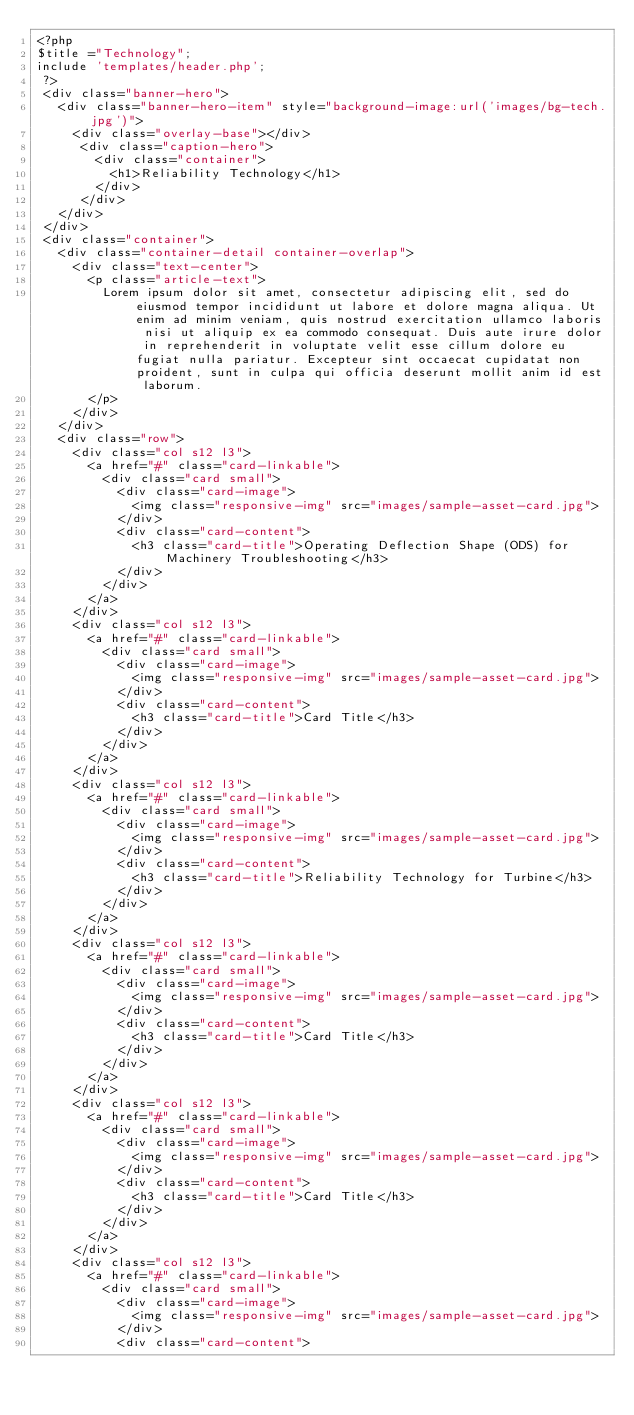<code> <loc_0><loc_0><loc_500><loc_500><_PHP_><?php
$title ="Technology";
include 'templates/header.php';
 ?>
 <div class="banner-hero">
   <div class="banner-hero-item" style="background-image:url('images/bg-tech.jpg')">
     <div class="overlay-base"></div>
      <div class="caption-hero">
        <div class="container">
          <h1>Reliability Technology</h1>
        </div>
      </div>
   </div>
 </div>
 <div class="container">
   <div class="container-detail container-overlap">
     <div class="text-center">
       <p class="article-text">
         Lorem ipsum dolor sit amet, consectetur adipiscing elit, sed do eiusmod tempor incididunt ut labore et dolore magna aliqua. Ut enim ad minim veniam, quis nostrud exercitation ullamco laboris nisi ut aliquip ex ea commodo consequat. Duis aute irure dolor in reprehenderit in voluptate velit esse cillum dolore eu fugiat nulla pariatur. Excepteur sint occaecat cupidatat non proident, sunt in culpa qui officia deserunt mollit anim id est laborum.
       </p>
     </div>
   </div>
   <div class="row">
     <div class="col s12 l3">
       <a href="#" class="card-linkable">
         <div class="card small">
           <div class="card-image">
             <img class="responsive-img" src="images/sample-asset-card.jpg">
           </div>
           <div class="card-content">
             <h3 class="card-title">Operating Deflection Shape (ODS) for Machinery Troubleshooting</h3>
           </div>
         </div>
       </a>
     </div>
     <div class="col s12 l3">
       <a href="#" class="card-linkable">
         <div class="card small">
           <div class="card-image">
             <img class="responsive-img" src="images/sample-asset-card.jpg">
           </div>
           <div class="card-content">
             <h3 class="card-title">Card Title</h3>
           </div>
         </div>
       </a>
     </div>
     <div class="col s12 l3">
       <a href="#" class="card-linkable">
         <div class="card small">
           <div class="card-image">
             <img class="responsive-img" src="images/sample-asset-card.jpg">
           </div>
           <div class="card-content">
             <h3 class="card-title">Reliability Technology for Turbine</h3>
           </div>
         </div>
       </a>
     </div>
     <div class="col s12 l3">
       <a href="#" class="card-linkable">
         <div class="card small">
           <div class="card-image">
             <img class="responsive-img" src="images/sample-asset-card.jpg">
           </div>
           <div class="card-content">
             <h3 class="card-title">Card Title</h3>
           </div>
         </div>
       </a>
     </div>
     <div class="col s12 l3">
       <a href="#" class="card-linkable">
         <div class="card small">
           <div class="card-image">
             <img class="responsive-img" src="images/sample-asset-card.jpg">
           </div>
           <div class="card-content">
             <h3 class="card-title">Card Title</h3>
           </div>
         </div>
       </a>
     </div>
     <div class="col s12 l3">
       <a href="#" class="card-linkable">
         <div class="card small">
           <div class="card-image">
             <img class="responsive-img" src="images/sample-asset-card.jpg">
           </div>
           <div class="card-content"></code> 